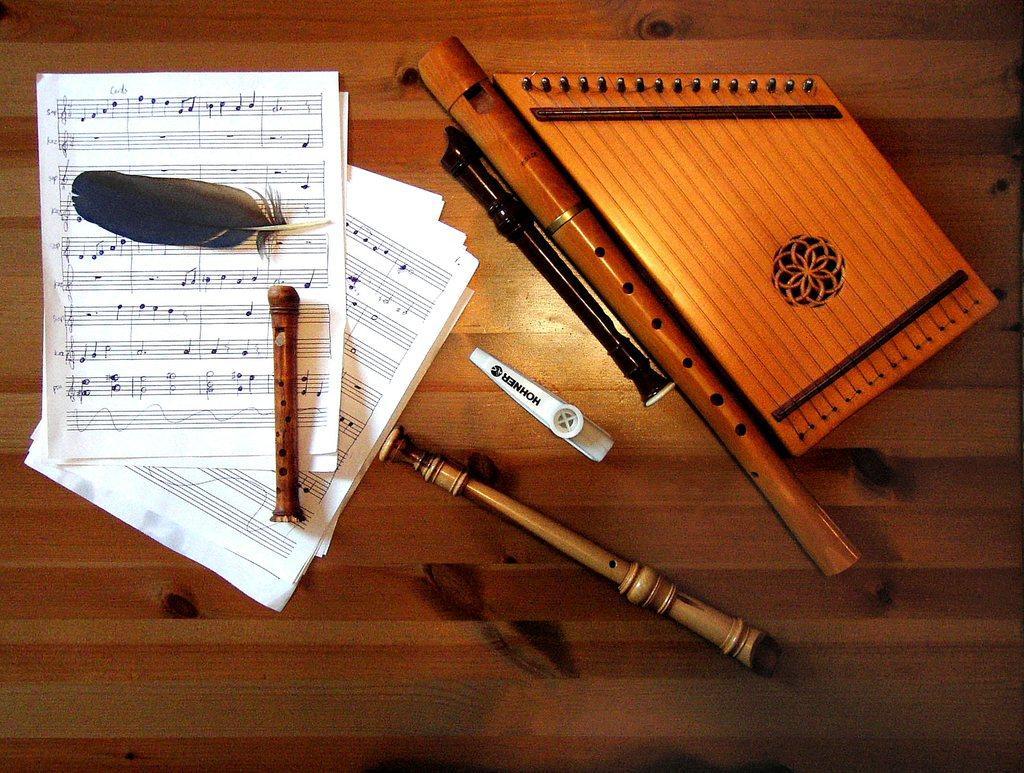Can you describe this image briefly? In this image, we can see few papers with feather and some stick, few musical instruments and white color object are placed on the wooden surface. 